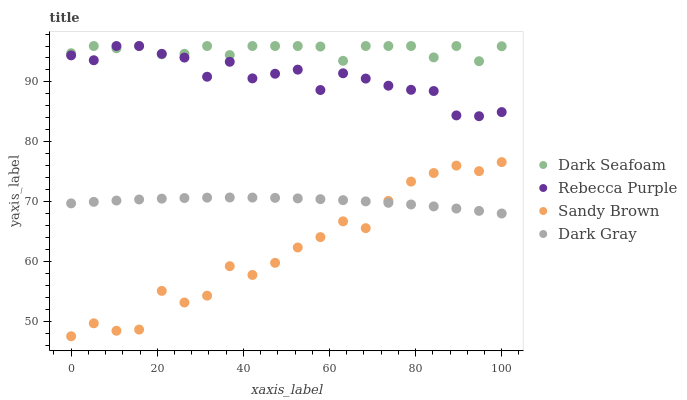Does Sandy Brown have the minimum area under the curve?
Answer yes or no. Yes. Does Dark Seafoam have the maximum area under the curve?
Answer yes or no. Yes. Does Dark Seafoam have the minimum area under the curve?
Answer yes or no. No. Does Sandy Brown have the maximum area under the curve?
Answer yes or no. No. Is Dark Gray the smoothest?
Answer yes or no. Yes. Is Sandy Brown the roughest?
Answer yes or no. Yes. Is Dark Seafoam the smoothest?
Answer yes or no. No. Is Dark Seafoam the roughest?
Answer yes or no. No. Does Sandy Brown have the lowest value?
Answer yes or no. Yes. Does Dark Seafoam have the lowest value?
Answer yes or no. No. Does Rebecca Purple have the highest value?
Answer yes or no. Yes. Does Sandy Brown have the highest value?
Answer yes or no. No. Is Dark Gray less than Rebecca Purple?
Answer yes or no. Yes. Is Rebecca Purple greater than Dark Gray?
Answer yes or no. Yes. Does Dark Gray intersect Sandy Brown?
Answer yes or no. Yes. Is Dark Gray less than Sandy Brown?
Answer yes or no. No. Is Dark Gray greater than Sandy Brown?
Answer yes or no. No. Does Dark Gray intersect Rebecca Purple?
Answer yes or no. No. 